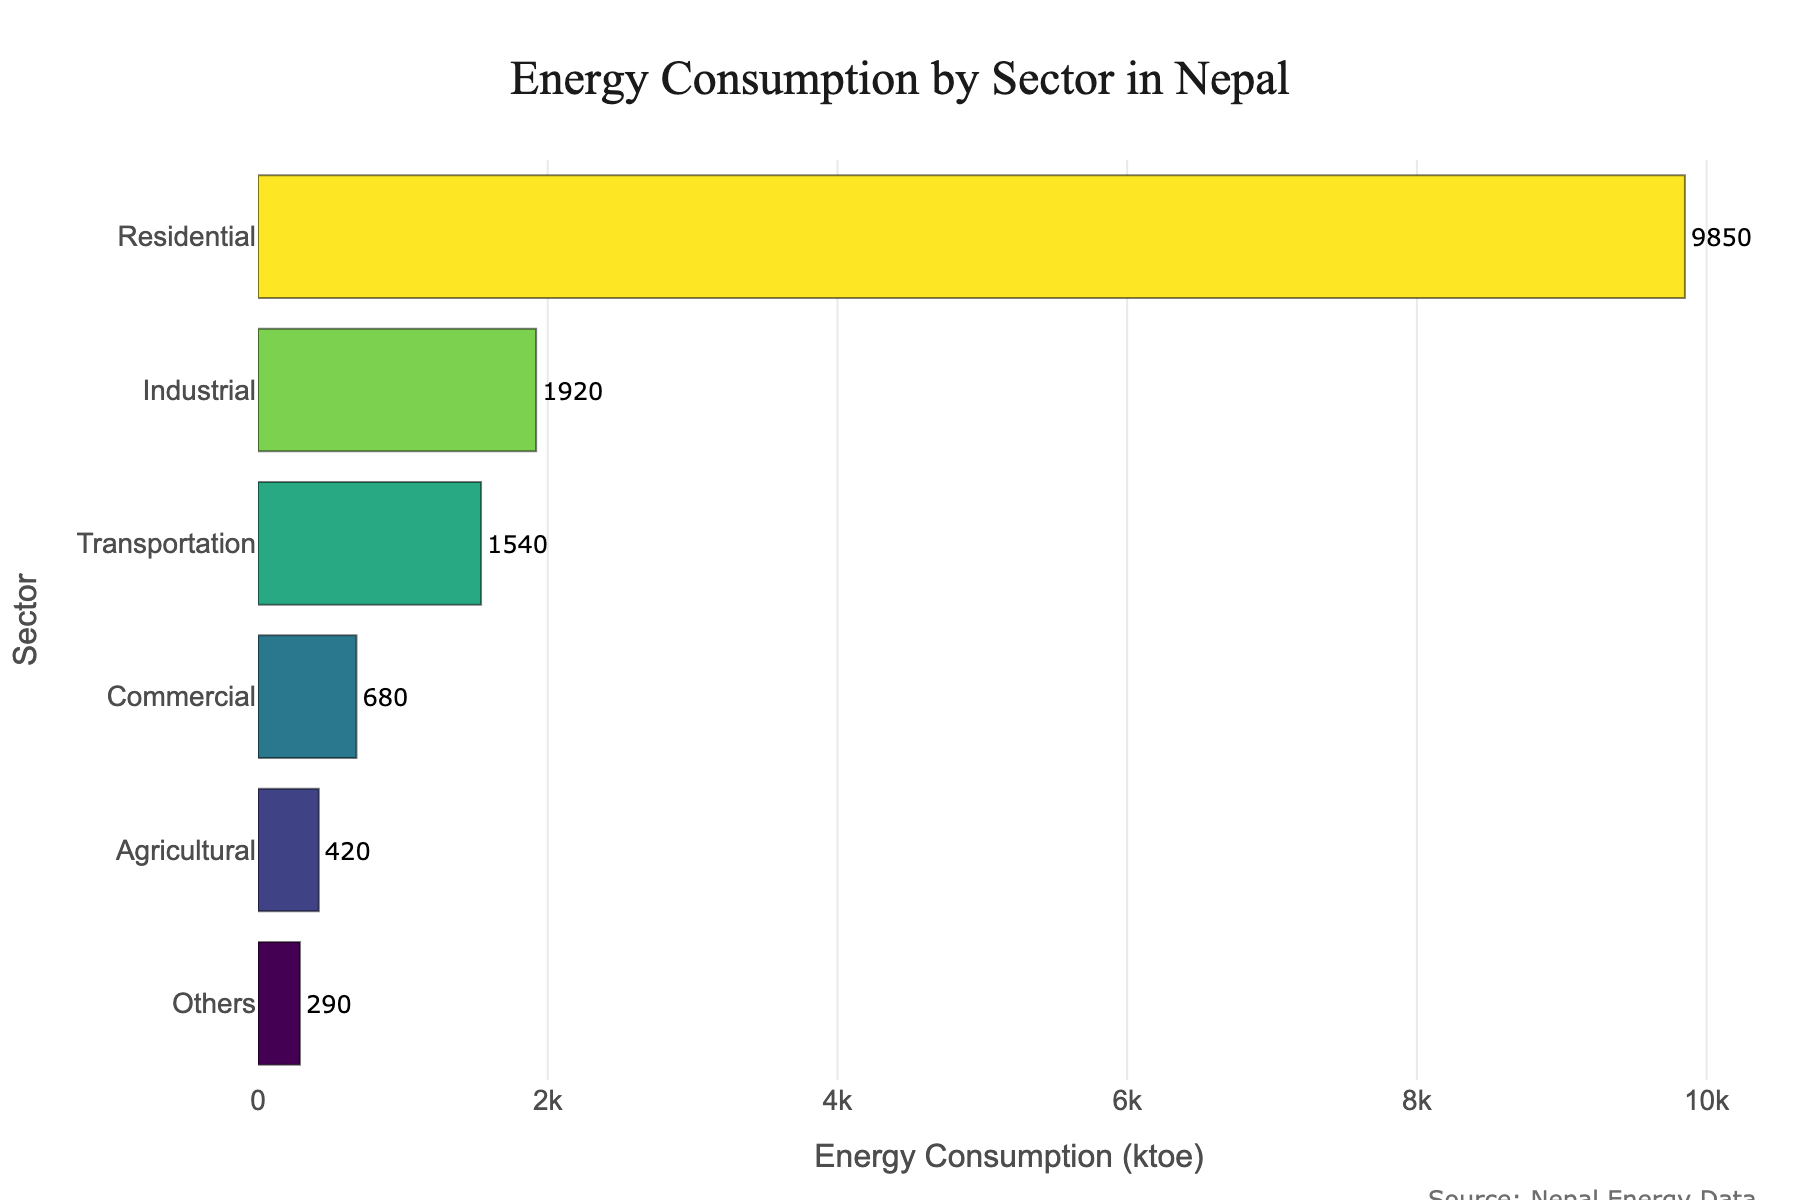Which sector consumes the most energy? The sector with the highest energy consumption will have the longest bar on the bar chart. By examining the chart, we can see that the 'Residential' sector has the longest bar.
Answer: Residential What is the total energy consumption of the Commercial and Agricultural sectors combined? Add the energy consumption values of the Commercial (680 ktoe) and Agricultural (420 ktoe) sectors. 680 + 420 = 1100 ktoe.
Answer: 1100 ktoe How much more energy does the Industrial sector consume compared to the Transportation sector? Subtract the energy consumption of the Transportation sector (1540 ktoe) from the Industrial sector (1920 ktoe). 1920 - 1540 = 380 ktoe.
Answer: 380 ktoe Rank the sectors from the highest to lowest energy consumption. Examine the lengths of the bars and order them from the longest to the shortest. The order is Residential (9850 ktoe), Industrial (1920 ktoe), Transportation (1540 ktoe), Commercial (680 ktoe), Agricultural (420 ktoe), Others (290 ktoe).
Answer: Residential, Industrial, Transportation, Commercial, Agricultural, Others What proportion of total energy consumption does the 'Others' sector represent? First, calculate the total energy consumption by summing the values for all sectors: 9850 + 1920 + 1540 + 680 + 420 + 290 = 14700 ktoe. Then, divide the energy consumption of the 'Others' sector by the total and multiply by 100 to get the percentage: (290 / 14700) * 100 = approximately 1.97%.
Answer: ~1.97% If the 'Commercial' sector's consumption were to double, would it surpass the 'Transportation' sector's consumption? Double the energy consumption of the 'Commercial' sector: 680 * 2 = 1360 ktoe. Compare this with the energy consumption of the 'Transportation' sector which is 1540 ktoe. Since 1360 is less than 1540, doubling the Commercial sector's consumption would still be less than that of the Transportation sector.
Answer: No What is the average energy consumption across all sectors? Sum the energy consumption values for all sectors and then divide by the number of sectors: (9850 + 1920 + 1540 + 680 + 420 + 290) / 6 = 14700 / 6 = 2450 ktoe.
Answer: 2450 ktoe Which sector has the shortest bar in the chart and what is its energy consumption? The shortest bar on the chart corresponds to the sector with the lowest energy consumption. This is the 'Others' sector, and its energy consumption is 290 ktoe.
Answer: Others, 290 ktoe How much less energy does the Agricultural sector consume than the sum of the Residential and Commercial sectors? First, find the sum of the Residential and Commercial sectors: 9850 + 680 = 10530 ktoe. Then, subtract the energy consumption of the Agricultural sector: 10530 - 420 = 10110 ktoe.
Answer: 10110 ktoe 